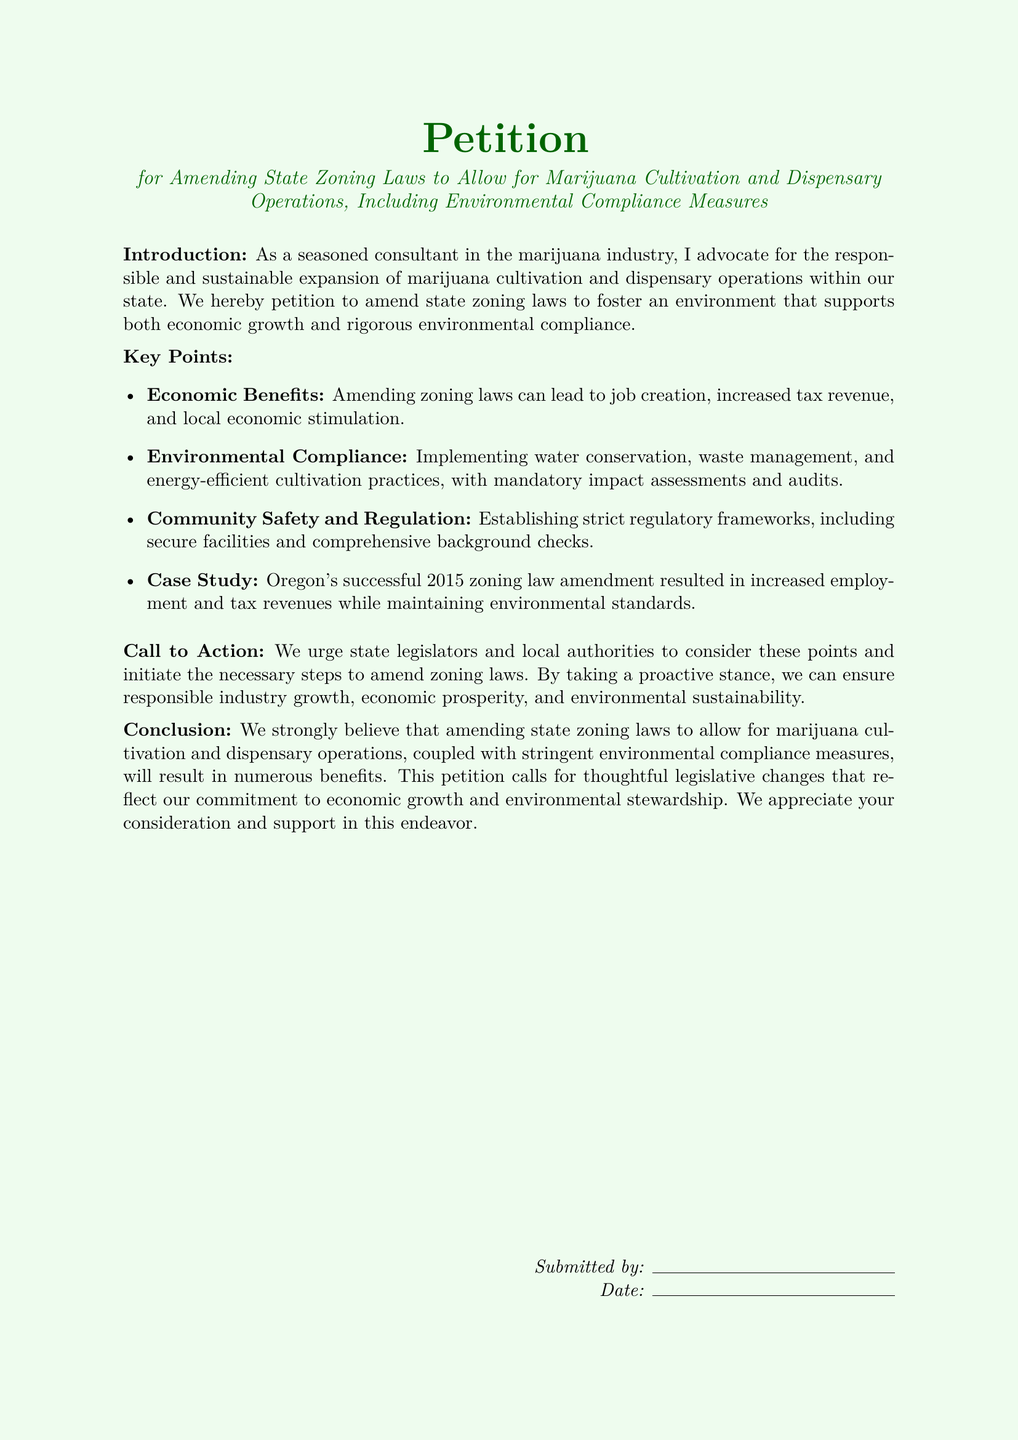What is the title of the petition? The title is the main heading that describes the content of the petition, which is "Petition for Amending State Zoning Laws to Allow for Marijuana Cultivation and Dispensary Operations, Including Environmental Compliance Measures."
Answer: Petition for Amending State Zoning Laws to Allow for Marijuana Cultivation and Dispensary Operations, Including Environmental Compliance Measures What are the key points outlined in the petition? Key points are major highlights or arguments presented in the petition. The key points are Economic Benefits, Environmental Compliance, Community Safety and Regulation, and Case Study.
Answer: Economic Benefits, Environmental Compliance, Community Safety and Regulation, Case Study What year did Oregon amend its zoning law? The year indicates when a significant case study took place, which is mentioned in the petition as 2015.
Answer: 2015 What is emphasized as a component of Environmental Compliance? This aspect refers specifically to practices being proposed to ensure environmental safety and sustainability, which includes water conservation.
Answer: Water conservation What is the call to action in this petition? The call to action conveys what the petitioners are urging state legislators and local authorities to do, specifically to consider points and initiate steps to amend zoning laws.
Answer: Consider these points and initiate the necessary steps to amend zoning laws What does the petition advocate for? The overall goal of the petition represents the broader aim and purpose, which is the responsibility and sustainable expansion of marijuana operations.
Answer: Responsible and sustainable expansion Who submitted the petition? This refers to the individual or group that formally put the petition forward, represented by a placeholder in the document.
Answer: Submitted by: [Name placeholder] What does the conclusion express? The conclusion summarizes the petition's main argument for changing laws, emphasizing a commitment to both economic growth and environmental stewardship.
Answer: Economic growth and environmental stewardship 